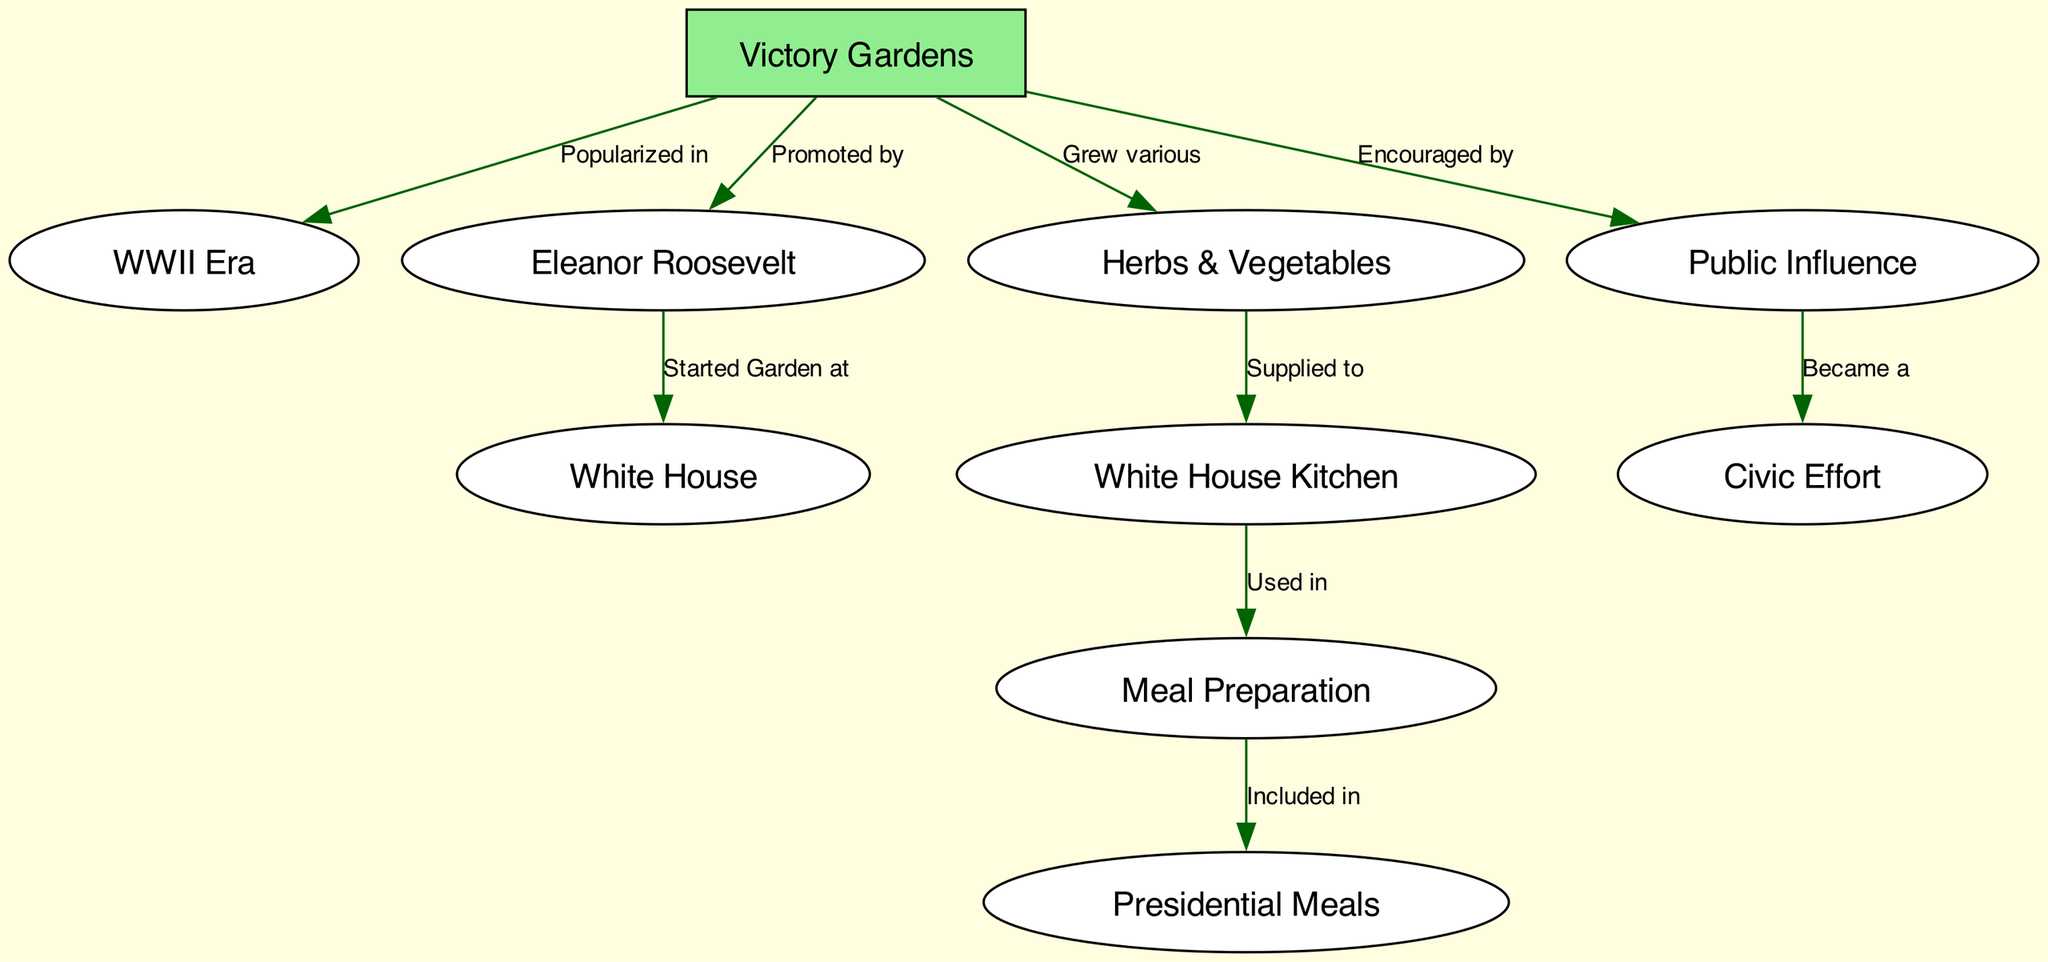What popularized Victory Gardens? The diagram indicates that Victory Gardens were popularized in the WWII Era. This can be directly inferred from the edge connecting "Victory Gardens" to "WWII," labeled "Popularized in."
Answer: WWII Era Who promoted Victory Gardens? According to the diagram, Victory Gardens were promoted by Eleanor Roosevelt, as seen in the edge connecting "Victory Gardens" to "Eleanor Roosevelt," labeled "Promoted by."
Answer: Eleanor Roosevelt Where did Eleanor Roosevelt start a garden? The diagram shows that Eleanor Roosevelt started a garden at the White House, denoted by the edge linking "Eleanor Roosevelt" to "White House," labeled "Started Garden at."
Answer: White House What type of plants were grown in Victory Gardens? The diagram states that various herbs and vegetables were grown in Victory Gardens, indicated by the edge linking "Victory Gardens" to "Herbs," labeled "Grew various."
Answer: Herbs & Vegetables What role did herbs play in Presidential meals? The diagram illustrates that herbs were supplied to the White House Kitchen and used in meal preparation, which eventually included presidential meals. This chain of connections leads from "Herbs" to "Kitchen," then to "Meal Preparation," and finally to "Presidents Meals."
Answer: Included in What civic effort did Victory Gardens encourage? The diagram depicts that Victory Gardens encouraged a civic effort, as shown by the edge connecting "Victory Gardens" to "Public Influence," which subsequently leads to "Civic Effort." The labeling "Became a" specifies this relationship.
Answer: Civic Effort How many nodes are present in the diagram? By counting the entries in the "nodes" section of the diagram data, we find there are 10 distinct nodes representing different elements of the food chain.
Answer: 10 What is the relationship between Victory Gardens and public influence? The diagram shows that Victory Gardens encouraged public influence, as indicated by the edge connecting "Victory Gardens" to "Public Influence," with the label "Encouraged by."
Answer: Encouraged by What is the function of the White House Kitchen in this food chain? The White House Kitchen serves the purpose of meal preparation as indicated by the edge linking "Kitchen" to "Meal Preparation," labeled "Used in." This signifies its integral role in the process of preparing meals that include ingredients from Victory Gardens.
Answer: Used in 